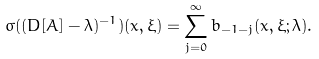Convert formula to latex. <formula><loc_0><loc_0><loc_500><loc_500>\sigma ( ( D [ A ] - \lambda ) ^ { - 1 } ) ( x , \xi ) = \sum _ { j = 0 } ^ { \infty } b _ { - 1 - j } ( x , \xi ; \lambda ) .</formula> 